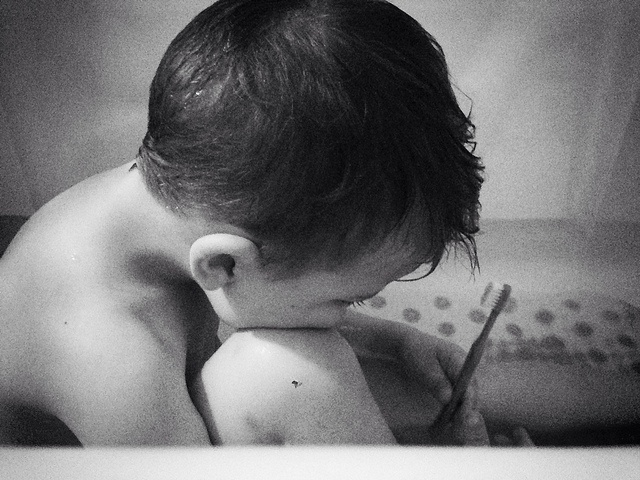Describe the objects in this image and their specific colors. I can see people in black, gray, darkgray, and lightgray tones and toothbrush in black, gray, and darkgray tones in this image. 